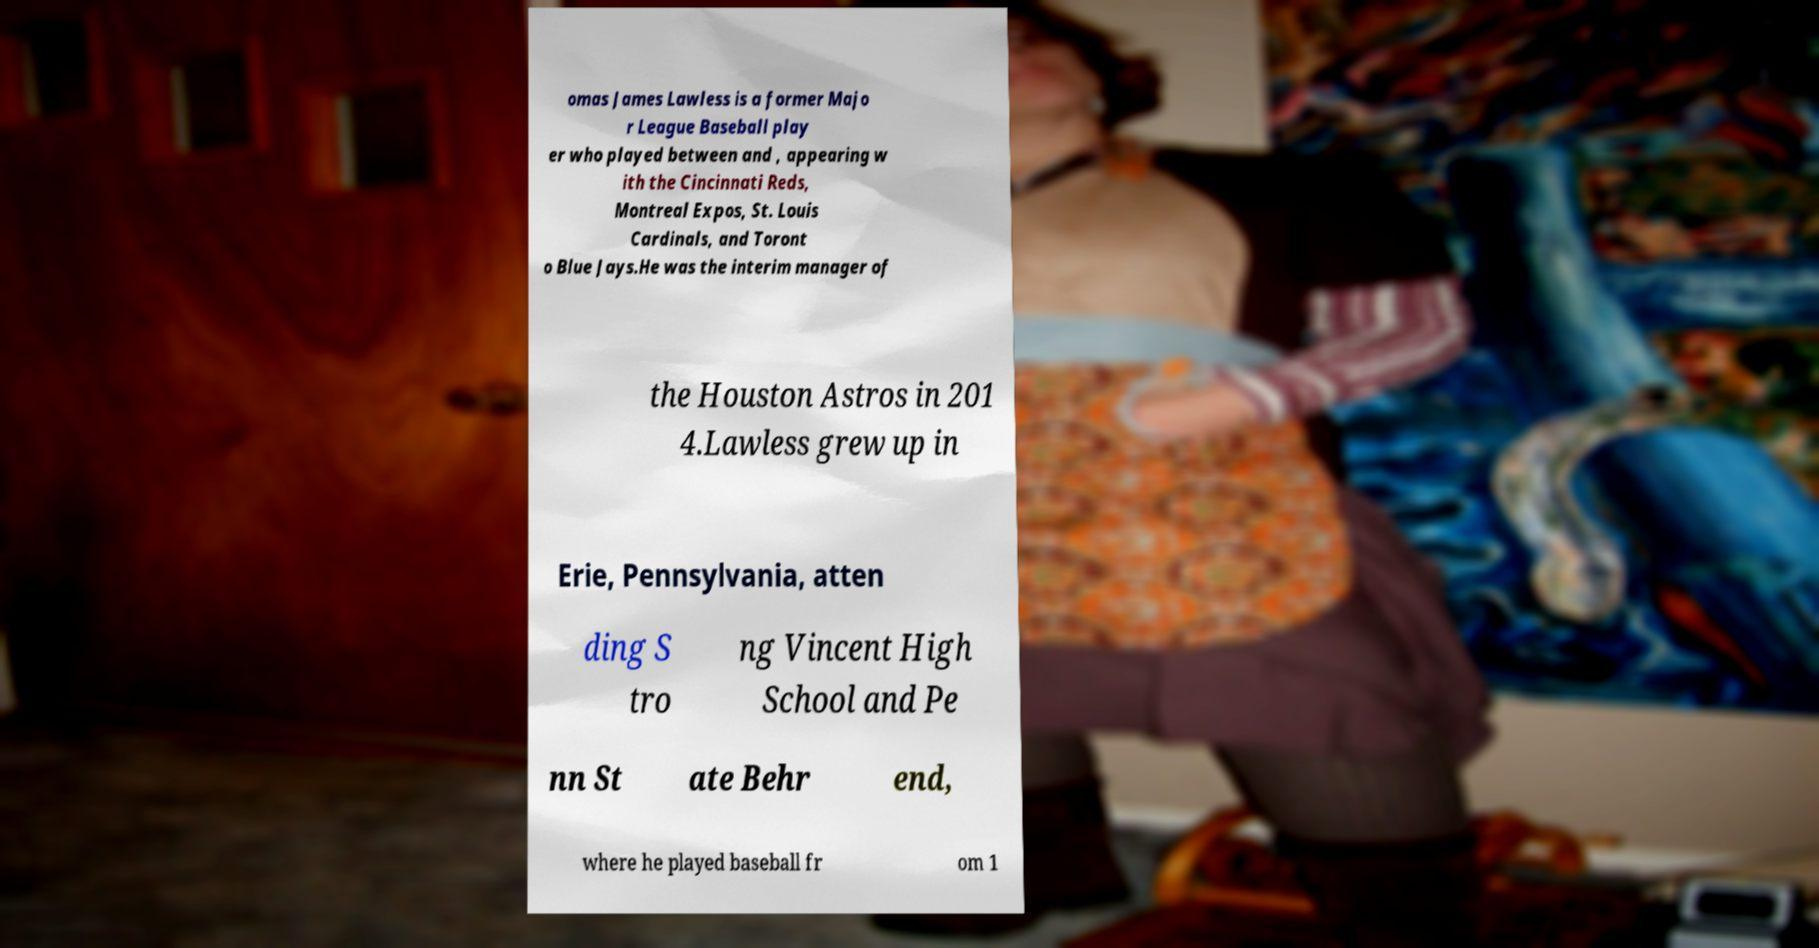Can you read and provide the text displayed in the image?This photo seems to have some interesting text. Can you extract and type it out for me? omas James Lawless is a former Majo r League Baseball play er who played between and , appearing w ith the Cincinnati Reds, Montreal Expos, St. Louis Cardinals, and Toront o Blue Jays.He was the interim manager of the Houston Astros in 201 4.Lawless grew up in Erie, Pennsylvania, atten ding S tro ng Vincent High School and Pe nn St ate Behr end, where he played baseball fr om 1 